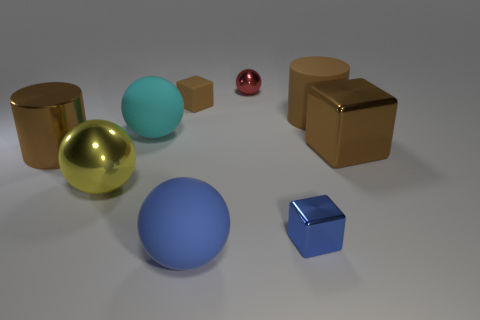How many cyan balls are the same size as the yellow metal sphere? 1 